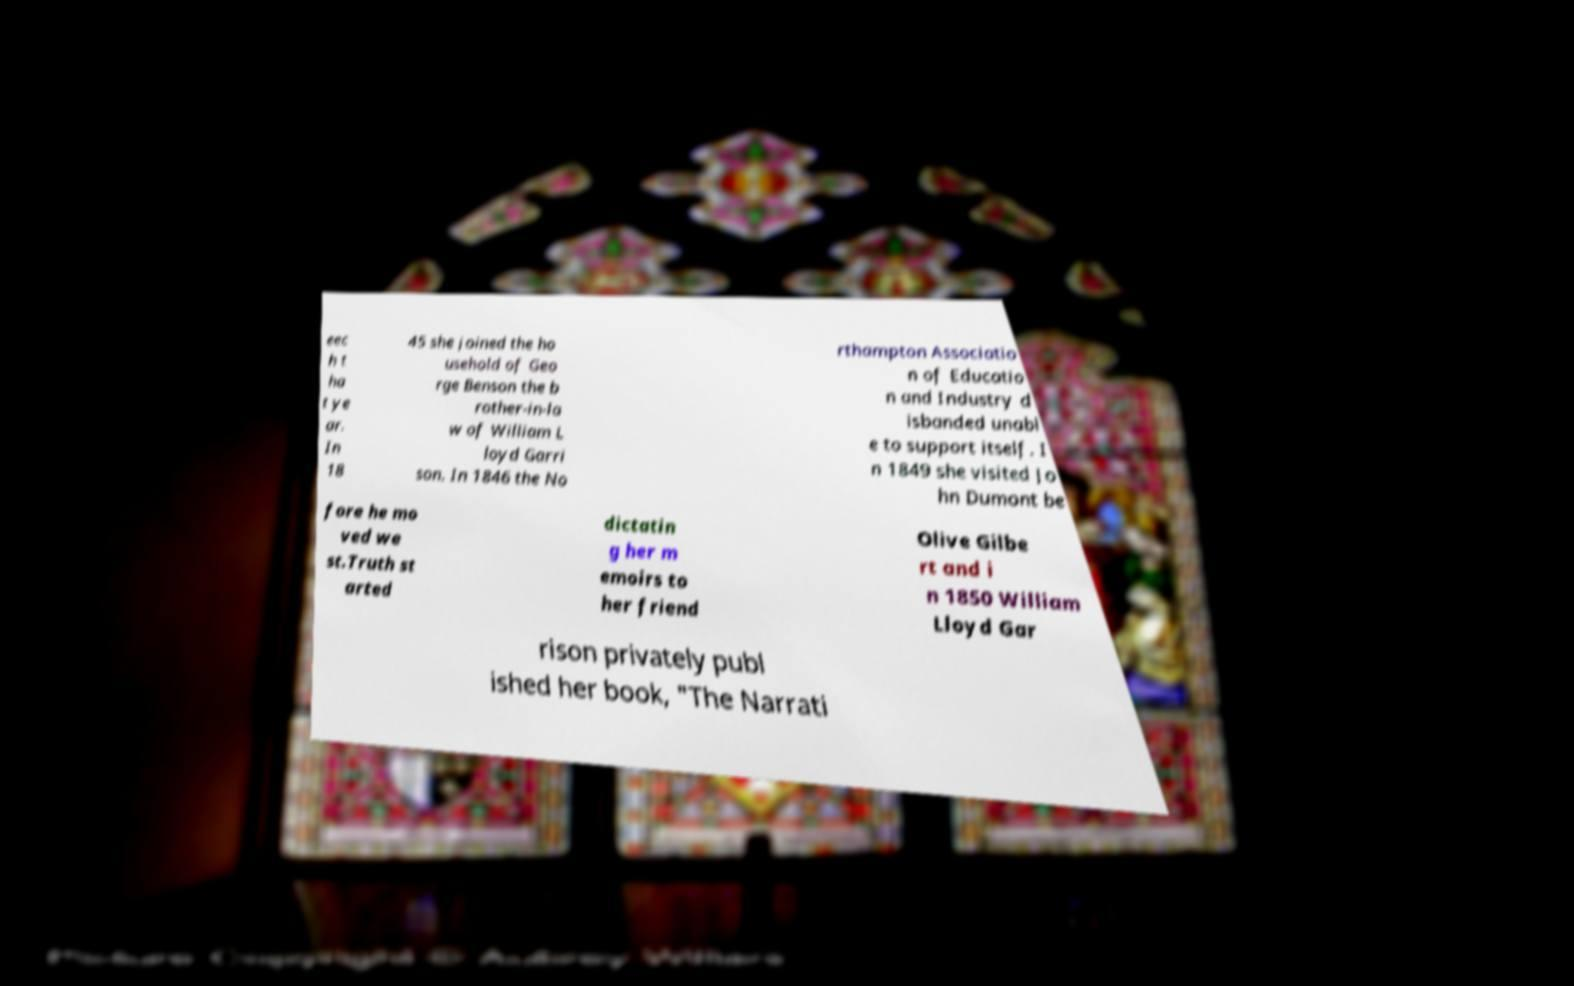Please read and relay the text visible in this image. What does it say? eec h t ha t ye ar. In 18 45 she joined the ho usehold of Geo rge Benson the b rother-in-la w of William L loyd Garri son. In 1846 the No rthampton Associatio n of Educatio n and Industry d isbanded unabl e to support itself. I n 1849 she visited Jo hn Dumont be fore he mo ved we st.Truth st arted dictatin g her m emoirs to her friend Olive Gilbe rt and i n 1850 William Lloyd Gar rison privately publ ished her book, "The Narrati 